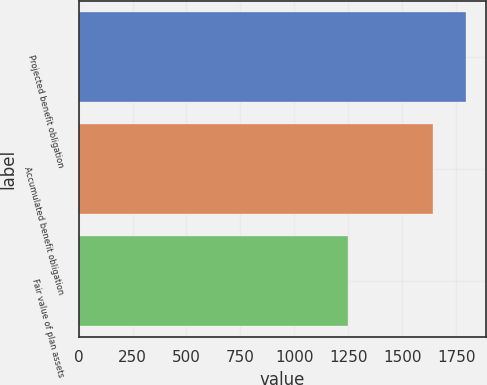Convert chart. <chart><loc_0><loc_0><loc_500><loc_500><bar_chart><fcel>Projected benefit obligation<fcel>Accumulated benefit obligation<fcel>Fair value of plan assets<nl><fcel>1797.4<fcel>1640.5<fcel>1250.3<nl></chart> 